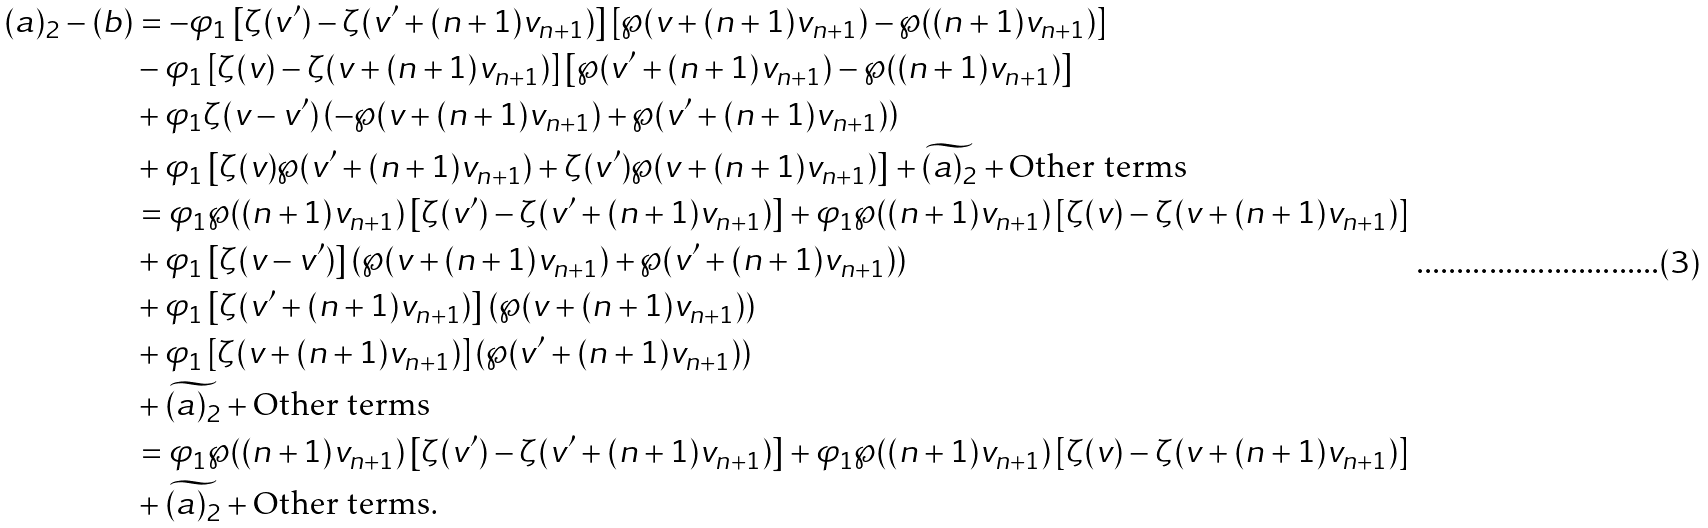Convert formula to latex. <formula><loc_0><loc_0><loc_500><loc_500>( a ) _ { 2 } - ( b ) & = - \varphi _ { 1 } \left [ \zeta ( v ^ { \prime } ) - \zeta ( v ^ { \prime } + ( n + 1 ) v _ { n + 1 } ) \right ] \left [ \wp ( v + ( n + 1 ) v _ { n + 1 } ) - \wp ( ( n + 1 ) v _ { n + 1 } ) \right ] \\ & - \varphi _ { 1 } \left [ \zeta ( v ) - \zeta ( v + ( n + 1 ) v _ { n + 1 } ) \right ] \left [ \wp ( v ^ { \prime } + ( n + 1 ) v _ { n + 1 } ) - \wp ( ( n + 1 ) v _ { n + 1 } ) \right ] \\ & + \varphi _ { 1 } \zeta ( v - v ^ { \prime } ) \left ( - \wp ( v + ( n + 1 ) v _ { n + 1 } ) + \wp ( v ^ { \prime } + ( n + 1 ) v _ { n + 1 } ) \right ) \\ & + \varphi _ { 1 } \left [ \zeta ( v ) \wp ( v ^ { \prime } + ( n + 1 ) v _ { n + 1 } ) + \zeta ( v ^ { \prime } ) \wp ( v + ( n + 1 ) v _ { n + 1 } ) \right ] + \widetilde { ( a ) _ { 2 } } + \text {Other terms} \\ & = \varphi _ { 1 } \wp ( ( n + 1 ) v _ { n + 1 } ) \left [ \zeta ( v ^ { \prime } ) - \zeta ( v ^ { \prime } + ( n + 1 ) v _ { n + 1 } ) \right ] + \varphi _ { 1 } \wp ( ( n + 1 ) v _ { n + 1 } ) \left [ \zeta ( v ) - \zeta ( v + ( n + 1 ) v _ { n + 1 } ) \right ] \\ & + \varphi _ { 1 } \left [ \zeta ( v - v ^ { \prime } ) \right ] \left ( \wp ( v + ( n + 1 ) v _ { n + 1 } ) + \wp ( v ^ { \prime } + ( n + 1 ) v _ { n + 1 } ) \right ) \\ & + \varphi _ { 1 } \left [ \zeta ( v ^ { \prime } + ( n + 1 ) v _ { n + 1 } ) \right ] \left ( \wp ( v + ( n + 1 ) v _ { n + 1 } ) \right ) \\ & + \varphi _ { 1 } \left [ \zeta ( v + ( n + 1 ) v _ { n + 1 } ) \right ] \left ( \wp ( v ^ { \prime } + ( n + 1 ) v _ { n + 1 } ) \right ) \\ & + \widetilde { ( a ) _ { 2 } } + \text {Other terms} \\ & = \varphi _ { 1 } \wp ( ( n + 1 ) v _ { n + 1 } ) \left [ \zeta ( v ^ { \prime } ) - \zeta ( v ^ { \prime } + ( n + 1 ) v _ { n + 1 } ) \right ] + \varphi _ { 1 } \wp ( ( n + 1 ) v _ { n + 1 } ) \left [ \zeta ( v ) - \zeta ( v + ( n + 1 ) v _ { n + 1 } ) \right ] \\ & + \widetilde { ( a ) _ { 2 } } + \text {Other terms} . \\</formula> 